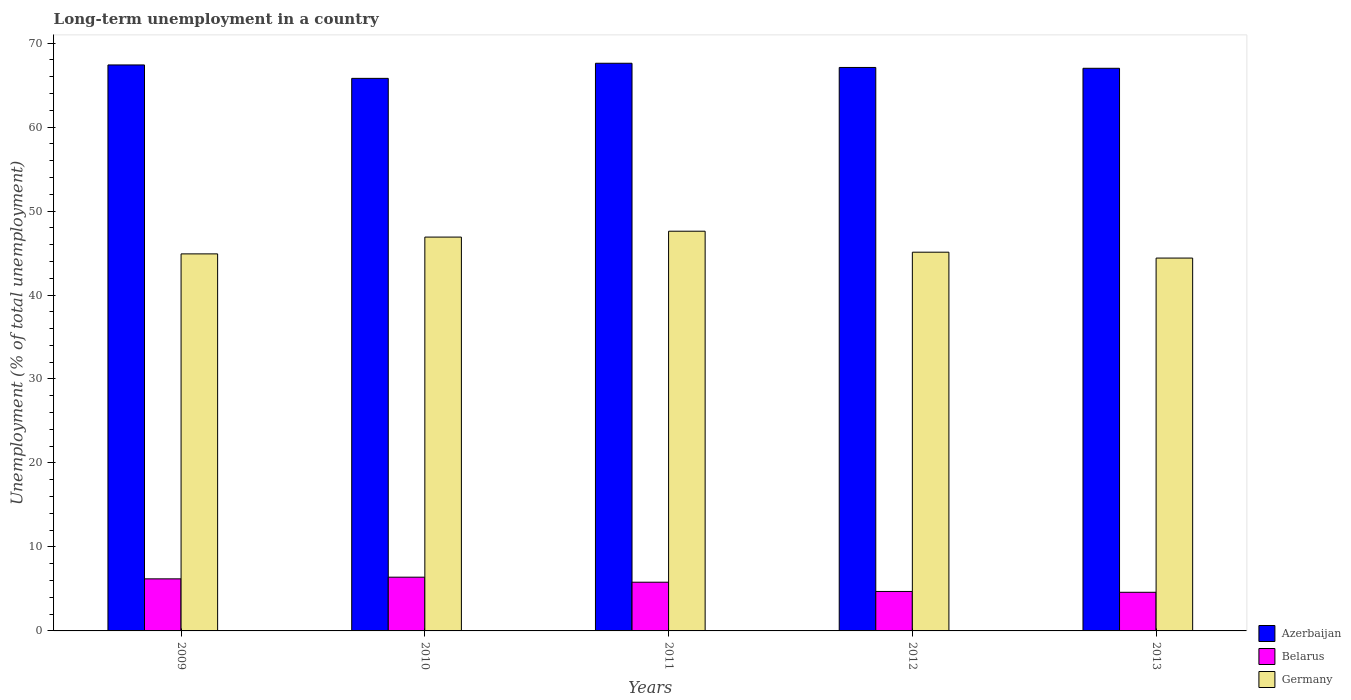How many groups of bars are there?
Provide a short and direct response. 5. How many bars are there on the 1st tick from the left?
Provide a succinct answer. 3. What is the label of the 2nd group of bars from the left?
Your answer should be compact. 2010. In how many cases, is the number of bars for a given year not equal to the number of legend labels?
Your response must be concise. 0. What is the percentage of long-term unemployed population in Germany in 2012?
Keep it short and to the point. 45.1. Across all years, what is the maximum percentage of long-term unemployed population in Belarus?
Your answer should be very brief. 6.4. Across all years, what is the minimum percentage of long-term unemployed population in Germany?
Give a very brief answer. 44.4. In which year was the percentage of long-term unemployed population in Belarus minimum?
Ensure brevity in your answer.  2013. What is the total percentage of long-term unemployed population in Azerbaijan in the graph?
Offer a terse response. 334.9. What is the difference between the percentage of long-term unemployed population in Azerbaijan in 2010 and that in 2012?
Offer a very short reply. -1.3. What is the difference between the percentage of long-term unemployed population in Azerbaijan in 2012 and the percentage of long-term unemployed population in Belarus in 2013?
Offer a very short reply. 62.5. What is the average percentage of long-term unemployed population in Azerbaijan per year?
Your response must be concise. 66.98. In the year 2013, what is the difference between the percentage of long-term unemployed population in Azerbaijan and percentage of long-term unemployed population in Germany?
Your answer should be very brief. 22.6. In how many years, is the percentage of long-term unemployed population in Azerbaijan greater than 36 %?
Give a very brief answer. 5. What is the ratio of the percentage of long-term unemployed population in Belarus in 2009 to that in 2010?
Keep it short and to the point. 0.97. Is the percentage of long-term unemployed population in Germany in 2009 less than that in 2012?
Offer a terse response. Yes. Is the difference between the percentage of long-term unemployed population in Azerbaijan in 2010 and 2012 greater than the difference between the percentage of long-term unemployed population in Germany in 2010 and 2012?
Your answer should be compact. No. What is the difference between the highest and the second highest percentage of long-term unemployed population in Germany?
Provide a short and direct response. 0.7. What is the difference between the highest and the lowest percentage of long-term unemployed population in Germany?
Give a very brief answer. 3.2. In how many years, is the percentage of long-term unemployed population in Germany greater than the average percentage of long-term unemployed population in Germany taken over all years?
Your answer should be very brief. 2. Is the sum of the percentage of long-term unemployed population in Germany in 2010 and 2012 greater than the maximum percentage of long-term unemployed population in Azerbaijan across all years?
Your answer should be very brief. Yes. Is it the case that in every year, the sum of the percentage of long-term unemployed population in Germany and percentage of long-term unemployed population in Belarus is greater than the percentage of long-term unemployed population in Azerbaijan?
Your response must be concise. No. Are all the bars in the graph horizontal?
Make the answer very short. No. How many years are there in the graph?
Provide a short and direct response. 5. What is the difference between two consecutive major ticks on the Y-axis?
Provide a succinct answer. 10. Are the values on the major ticks of Y-axis written in scientific E-notation?
Provide a short and direct response. No. Does the graph contain any zero values?
Provide a short and direct response. No. Does the graph contain grids?
Give a very brief answer. No. Where does the legend appear in the graph?
Ensure brevity in your answer.  Bottom right. What is the title of the graph?
Ensure brevity in your answer.  Long-term unemployment in a country. Does "High income" appear as one of the legend labels in the graph?
Offer a very short reply. No. What is the label or title of the Y-axis?
Make the answer very short. Unemployment (% of total unemployment). What is the Unemployment (% of total unemployment) of Azerbaijan in 2009?
Offer a very short reply. 67.4. What is the Unemployment (% of total unemployment) in Belarus in 2009?
Your response must be concise. 6.2. What is the Unemployment (% of total unemployment) of Germany in 2009?
Your answer should be compact. 44.9. What is the Unemployment (% of total unemployment) of Azerbaijan in 2010?
Your answer should be very brief. 65.8. What is the Unemployment (% of total unemployment) in Belarus in 2010?
Your response must be concise. 6.4. What is the Unemployment (% of total unemployment) in Germany in 2010?
Provide a succinct answer. 46.9. What is the Unemployment (% of total unemployment) in Azerbaijan in 2011?
Offer a terse response. 67.6. What is the Unemployment (% of total unemployment) of Belarus in 2011?
Ensure brevity in your answer.  5.8. What is the Unemployment (% of total unemployment) in Germany in 2011?
Provide a short and direct response. 47.6. What is the Unemployment (% of total unemployment) of Azerbaijan in 2012?
Make the answer very short. 67.1. What is the Unemployment (% of total unemployment) of Belarus in 2012?
Make the answer very short. 4.7. What is the Unemployment (% of total unemployment) of Germany in 2012?
Keep it short and to the point. 45.1. What is the Unemployment (% of total unemployment) of Azerbaijan in 2013?
Your answer should be very brief. 67. What is the Unemployment (% of total unemployment) of Belarus in 2013?
Provide a short and direct response. 4.6. What is the Unemployment (% of total unemployment) in Germany in 2013?
Your response must be concise. 44.4. Across all years, what is the maximum Unemployment (% of total unemployment) in Azerbaijan?
Make the answer very short. 67.6. Across all years, what is the maximum Unemployment (% of total unemployment) of Belarus?
Offer a terse response. 6.4. Across all years, what is the maximum Unemployment (% of total unemployment) of Germany?
Give a very brief answer. 47.6. Across all years, what is the minimum Unemployment (% of total unemployment) in Azerbaijan?
Give a very brief answer. 65.8. Across all years, what is the minimum Unemployment (% of total unemployment) in Belarus?
Make the answer very short. 4.6. Across all years, what is the minimum Unemployment (% of total unemployment) of Germany?
Keep it short and to the point. 44.4. What is the total Unemployment (% of total unemployment) in Azerbaijan in the graph?
Keep it short and to the point. 334.9. What is the total Unemployment (% of total unemployment) of Belarus in the graph?
Your response must be concise. 27.7. What is the total Unemployment (% of total unemployment) of Germany in the graph?
Give a very brief answer. 228.9. What is the difference between the Unemployment (% of total unemployment) in Azerbaijan in 2009 and that in 2010?
Make the answer very short. 1.6. What is the difference between the Unemployment (% of total unemployment) of Azerbaijan in 2009 and that in 2011?
Your answer should be very brief. -0.2. What is the difference between the Unemployment (% of total unemployment) in Belarus in 2009 and that in 2011?
Ensure brevity in your answer.  0.4. What is the difference between the Unemployment (% of total unemployment) of Azerbaijan in 2009 and that in 2012?
Offer a very short reply. 0.3. What is the difference between the Unemployment (% of total unemployment) in Belarus in 2009 and that in 2013?
Make the answer very short. 1.6. What is the difference between the Unemployment (% of total unemployment) in Azerbaijan in 2010 and that in 2011?
Give a very brief answer. -1.8. What is the difference between the Unemployment (% of total unemployment) in Belarus in 2010 and that in 2011?
Your answer should be compact. 0.6. What is the difference between the Unemployment (% of total unemployment) in Belarus in 2010 and that in 2012?
Your answer should be compact. 1.7. What is the difference between the Unemployment (% of total unemployment) of Belarus in 2010 and that in 2013?
Your response must be concise. 1.8. What is the difference between the Unemployment (% of total unemployment) in Germany in 2010 and that in 2013?
Your answer should be very brief. 2.5. What is the difference between the Unemployment (% of total unemployment) of Azerbaijan in 2011 and that in 2012?
Provide a short and direct response. 0.5. What is the difference between the Unemployment (% of total unemployment) in Belarus in 2011 and that in 2013?
Your answer should be compact. 1.2. What is the difference between the Unemployment (% of total unemployment) of Germany in 2012 and that in 2013?
Make the answer very short. 0.7. What is the difference between the Unemployment (% of total unemployment) in Azerbaijan in 2009 and the Unemployment (% of total unemployment) in Germany in 2010?
Your response must be concise. 20.5. What is the difference between the Unemployment (% of total unemployment) of Belarus in 2009 and the Unemployment (% of total unemployment) of Germany in 2010?
Ensure brevity in your answer.  -40.7. What is the difference between the Unemployment (% of total unemployment) in Azerbaijan in 2009 and the Unemployment (% of total unemployment) in Belarus in 2011?
Give a very brief answer. 61.6. What is the difference between the Unemployment (% of total unemployment) in Azerbaijan in 2009 and the Unemployment (% of total unemployment) in Germany in 2011?
Ensure brevity in your answer.  19.8. What is the difference between the Unemployment (% of total unemployment) of Belarus in 2009 and the Unemployment (% of total unemployment) of Germany in 2011?
Your answer should be very brief. -41.4. What is the difference between the Unemployment (% of total unemployment) in Azerbaijan in 2009 and the Unemployment (% of total unemployment) in Belarus in 2012?
Your answer should be very brief. 62.7. What is the difference between the Unemployment (% of total unemployment) in Azerbaijan in 2009 and the Unemployment (% of total unemployment) in Germany in 2012?
Your answer should be compact. 22.3. What is the difference between the Unemployment (% of total unemployment) of Belarus in 2009 and the Unemployment (% of total unemployment) of Germany in 2012?
Make the answer very short. -38.9. What is the difference between the Unemployment (% of total unemployment) of Azerbaijan in 2009 and the Unemployment (% of total unemployment) of Belarus in 2013?
Keep it short and to the point. 62.8. What is the difference between the Unemployment (% of total unemployment) of Belarus in 2009 and the Unemployment (% of total unemployment) of Germany in 2013?
Your answer should be very brief. -38.2. What is the difference between the Unemployment (% of total unemployment) in Belarus in 2010 and the Unemployment (% of total unemployment) in Germany in 2011?
Offer a terse response. -41.2. What is the difference between the Unemployment (% of total unemployment) of Azerbaijan in 2010 and the Unemployment (% of total unemployment) of Belarus in 2012?
Your answer should be very brief. 61.1. What is the difference between the Unemployment (% of total unemployment) of Azerbaijan in 2010 and the Unemployment (% of total unemployment) of Germany in 2012?
Give a very brief answer. 20.7. What is the difference between the Unemployment (% of total unemployment) of Belarus in 2010 and the Unemployment (% of total unemployment) of Germany in 2012?
Your response must be concise. -38.7. What is the difference between the Unemployment (% of total unemployment) of Azerbaijan in 2010 and the Unemployment (% of total unemployment) of Belarus in 2013?
Offer a very short reply. 61.2. What is the difference between the Unemployment (% of total unemployment) in Azerbaijan in 2010 and the Unemployment (% of total unemployment) in Germany in 2013?
Provide a short and direct response. 21.4. What is the difference between the Unemployment (% of total unemployment) of Belarus in 2010 and the Unemployment (% of total unemployment) of Germany in 2013?
Provide a succinct answer. -38. What is the difference between the Unemployment (% of total unemployment) of Azerbaijan in 2011 and the Unemployment (% of total unemployment) of Belarus in 2012?
Offer a terse response. 62.9. What is the difference between the Unemployment (% of total unemployment) of Belarus in 2011 and the Unemployment (% of total unemployment) of Germany in 2012?
Provide a short and direct response. -39.3. What is the difference between the Unemployment (% of total unemployment) in Azerbaijan in 2011 and the Unemployment (% of total unemployment) in Germany in 2013?
Give a very brief answer. 23.2. What is the difference between the Unemployment (% of total unemployment) of Belarus in 2011 and the Unemployment (% of total unemployment) of Germany in 2013?
Offer a very short reply. -38.6. What is the difference between the Unemployment (% of total unemployment) in Azerbaijan in 2012 and the Unemployment (% of total unemployment) in Belarus in 2013?
Provide a short and direct response. 62.5. What is the difference between the Unemployment (% of total unemployment) in Azerbaijan in 2012 and the Unemployment (% of total unemployment) in Germany in 2013?
Provide a short and direct response. 22.7. What is the difference between the Unemployment (% of total unemployment) in Belarus in 2012 and the Unemployment (% of total unemployment) in Germany in 2013?
Ensure brevity in your answer.  -39.7. What is the average Unemployment (% of total unemployment) of Azerbaijan per year?
Your response must be concise. 66.98. What is the average Unemployment (% of total unemployment) of Belarus per year?
Offer a terse response. 5.54. What is the average Unemployment (% of total unemployment) of Germany per year?
Offer a terse response. 45.78. In the year 2009, what is the difference between the Unemployment (% of total unemployment) in Azerbaijan and Unemployment (% of total unemployment) in Belarus?
Give a very brief answer. 61.2. In the year 2009, what is the difference between the Unemployment (% of total unemployment) in Azerbaijan and Unemployment (% of total unemployment) in Germany?
Make the answer very short. 22.5. In the year 2009, what is the difference between the Unemployment (% of total unemployment) of Belarus and Unemployment (% of total unemployment) of Germany?
Provide a short and direct response. -38.7. In the year 2010, what is the difference between the Unemployment (% of total unemployment) of Azerbaijan and Unemployment (% of total unemployment) of Belarus?
Offer a terse response. 59.4. In the year 2010, what is the difference between the Unemployment (% of total unemployment) in Belarus and Unemployment (% of total unemployment) in Germany?
Provide a short and direct response. -40.5. In the year 2011, what is the difference between the Unemployment (% of total unemployment) of Azerbaijan and Unemployment (% of total unemployment) of Belarus?
Ensure brevity in your answer.  61.8. In the year 2011, what is the difference between the Unemployment (% of total unemployment) of Belarus and Unemployment (% of total unemployment) of Germany?
Offer a very short reply. -41.8. In the year 2012, what is the difference between the Unemployment (% of total unemployment) of Azerbaijan and Unemployment (% of total unemployment) of Belarus?
Make the answer very short. 62.4. In the year 2012, what is the difference between the Unemployment (% of total unemployment) of Azerbaijan and Unemployment (% of total unemployment) of Germany?
Ensure brevity in your answer.  22. In the year 2012, what is the difference between the Unemployment (% of total unemployment) of Belarus and Unemployment (% of total unemployment) of Germany?
Keep it short and to the point. -40.4. In the year 2013, what is the difference between the Unemployment (% of total unemployment) of Azerbaijan and Unemployment (% of total unemployment) of Belarus?
Your answer should be very brief. 62.4. In the year 2013, what is the difference between the Unemployment (% of total unemployment) in Azerbaijan and Unemployment (% of total unemployment) in Germany?
Your answer should be very brief. 22.6. In the year 2013, what is the difference between the Unemployment (% of total unemployment) in Belarus and Unemployment (% of total unemployment) in Germany?
Keep it short and to the point. -39.8. What is the ratio of the Unemployment (% of total unemployment) of Azerbaijan in 2009 to that in 2010?
Provide a short and direct response. 1.02. What is the ratio of the Unemployment (% of total unemployment) in Belarus in 2009 to that in 2010?
Offer a terse response. 0.97. What is the ratio of the Unemployment (% of total unemployment) in Germany in 2009 to that in 2010?
Ensure brevity in your answer.  0.96. What is the ratio of the Unemployment (% of total unemployment) in Azerbaijan in 2009 to that in 2011?
Your answer should be very brief. 1. What is the ratio of the Unemployment (% of total unemployment) of Belarus in 2009 to that in 2011?
Your answer should be compact. 1.07. What is the ratio of the Unemployment (% of total unemployment) of Germany in 2009 to that in 2011?
Your answer should be very brief. 0.94. What is the ratio of the Unemployment (% of total unemployment) of Belarus in 2009 to that in 2012?
Provide a succinct answer. 1.32. What is the ratio of the Unemployment (% of total unemployment) in Belarus in 2009 to that in 2013?
Your response must be concise. 1.35. What is the ratio of the Unemployment (% of total unemployment) in Germany in 2009 to that in 2013?
Your response must be concise. 1.01. What is the ratio of the Unemployment (% of total unemployment) of Azerbaijan in 2010 to that in 2011?
Provide a succinct answer. 0.97. What is the ratio of the Unemployment (% of total unemployment) of Belarus in 2010 to that in 2011?
Make the answer very short. 1.1. What is the ratio of the Unemployment (% of total unemployment) in Germany in 2010 to that in 2011?
Keep it short and to the point. 0.99. What is the ratio of the Unemployment (% of total unemployment) in Azerbaijan in 2010 to that in 2012?
Keep it short and to the point. 0.98. What is the ratio of the Unemployment (% of total unemployment) in Belarus in 2010 to that in 2012?
Ensure brevity in your answer.  1.36. What is the ratio of the Unemployment (% of total unemployment) in Germany in 2010 to that in 2012?
Your response must be concise. 1.04. What is the ratio of the Unemployment (% of total unemployment) in Azerbaijan in 2010 to that in 2013?
Provide a short and direct response. 0.98. What is the ratio of the Unemployment (% of total unemployment) in Belarus in 2010 to that in 2013?
Provide a succinct answer. 1.39. What is the ratio of the Unemployment (% of total unemployment) in Germany in 2010 to that in 2013?
Make the answer very short. 1.06. What is the ratio of the Unemployment (% of total unemployment) of Azerbaijan in 2011 to that in 2012?
Your response must be concise. 1.01. What is the ratio of the Unemployment (% of total unemployment) in Belarus in 2011 to that in 2012?
Provide a succinct answer. 1.23. What is the ratio of the Unemployment (% of total unemployment) of Germany in 2011 to that in 2012?
Provide a succinct answer. 1.06. What is the ratio of the Unemployment (% of total unemployment) of Belarus in 2011 to that in 2013?
Provide a short and direct response. 1.26. What is the ratio of the Unemployment (% of total unemployment) of Germany in 2011 to that in 2013?
Make the answer very short. 1.07. What is the ratio of the Unemployment (% of total unemployment) of Azerbaijan in 2012 to that in 2013?
Offer a terse response. 1. What is the ratio of the Unemployment (% of total unemployment) in Belarus in 2012 to that in 2013?
Keep it short and to the point. 1.02. What is the ratio of the Unemployment (% of total unemployment) in Germany in 2012 to that in 2013?
Your response must be concise. 1.02. What is the difference between the highest and the second highest Unemployment (% of total unemployment) in Belarus?
Your response must be concise. 0.2. What is the difference between the highest and the second highest Unemployment (% of total unemployment) in Germany?
Provide a succinct answer. 0.7. What is the difference between the highest and the lowest Unemployment (% of total unemployment) of Azerbaijan?
Provide a succinct answer. 1.8. What is the difference between the highest and the lowest Unemployment (% of total unemployment) in Belarus?
Make the answer very short. 1.8. 